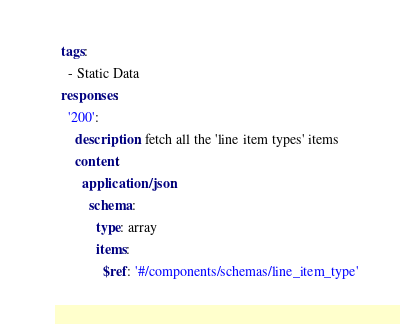Convert code to text. <code><loc_0><loc_0><loc_500><loc_500><_YAML_>  tags:
    - Static Data
  responses:
    '200':
      description: fetch all the 'line item types' items
      content:
        application/json:
          schema:
            type: array
            items:
              $ref: '#/components/schemas/line_item_type'
</code> 